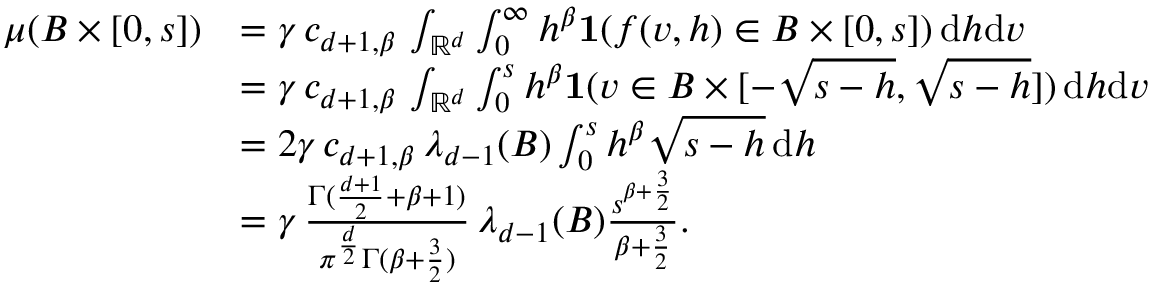<formula> <loc_0><loc_0><loc_500><loc_500>\begin{array} { r l } { \mu ( B \times [ 0 , s ] ) } & { = \gamma \, c _ { d + 1 , \beta } \, \int _ { \mathbb { R } ^ { d } } \int _ { 0 } ^ { \infty } h ^ { \beta } { 1 } ( f ( v , h ) \in B \times [ 0 , s ] ) \, d h d v } \\ & { = \gamma \, c _ { d + 1 , \beta } \, \int _ { \mathbb { R } ^ { d } } \int _ { 0 } ^ { s } h ^ { \beta } { 1 } ( v \in B \times [ - \sqrt { s - h } , \sqrt { s - h } ] ) \, d h d v } \\ & { = 2 \gamma \, c _ { d + 1 , \beta } \, \lambda _ { d - 1 } ( B ) \int _ { 0 } ^ { s } h ^ { \beta } \sqrt { s - h } \, d h } \\ & { = \gamma \, { \frac { \Gamma ( { \frac { d + 1 } { 2 } } + \beta + 1 ) } { \pi ^ { \frac { d } { 2 } } \Gamma ( \beta + { \frac { 3 } { 2 } } ) } } \, \lambda _ { d - 1 } ( B ) { \frac { s ^ { \beta + { \frac { 3 } { 2 } } } } { \beta + { \frac { 3 } { 2 } } } } . } \end{array}</formula> 